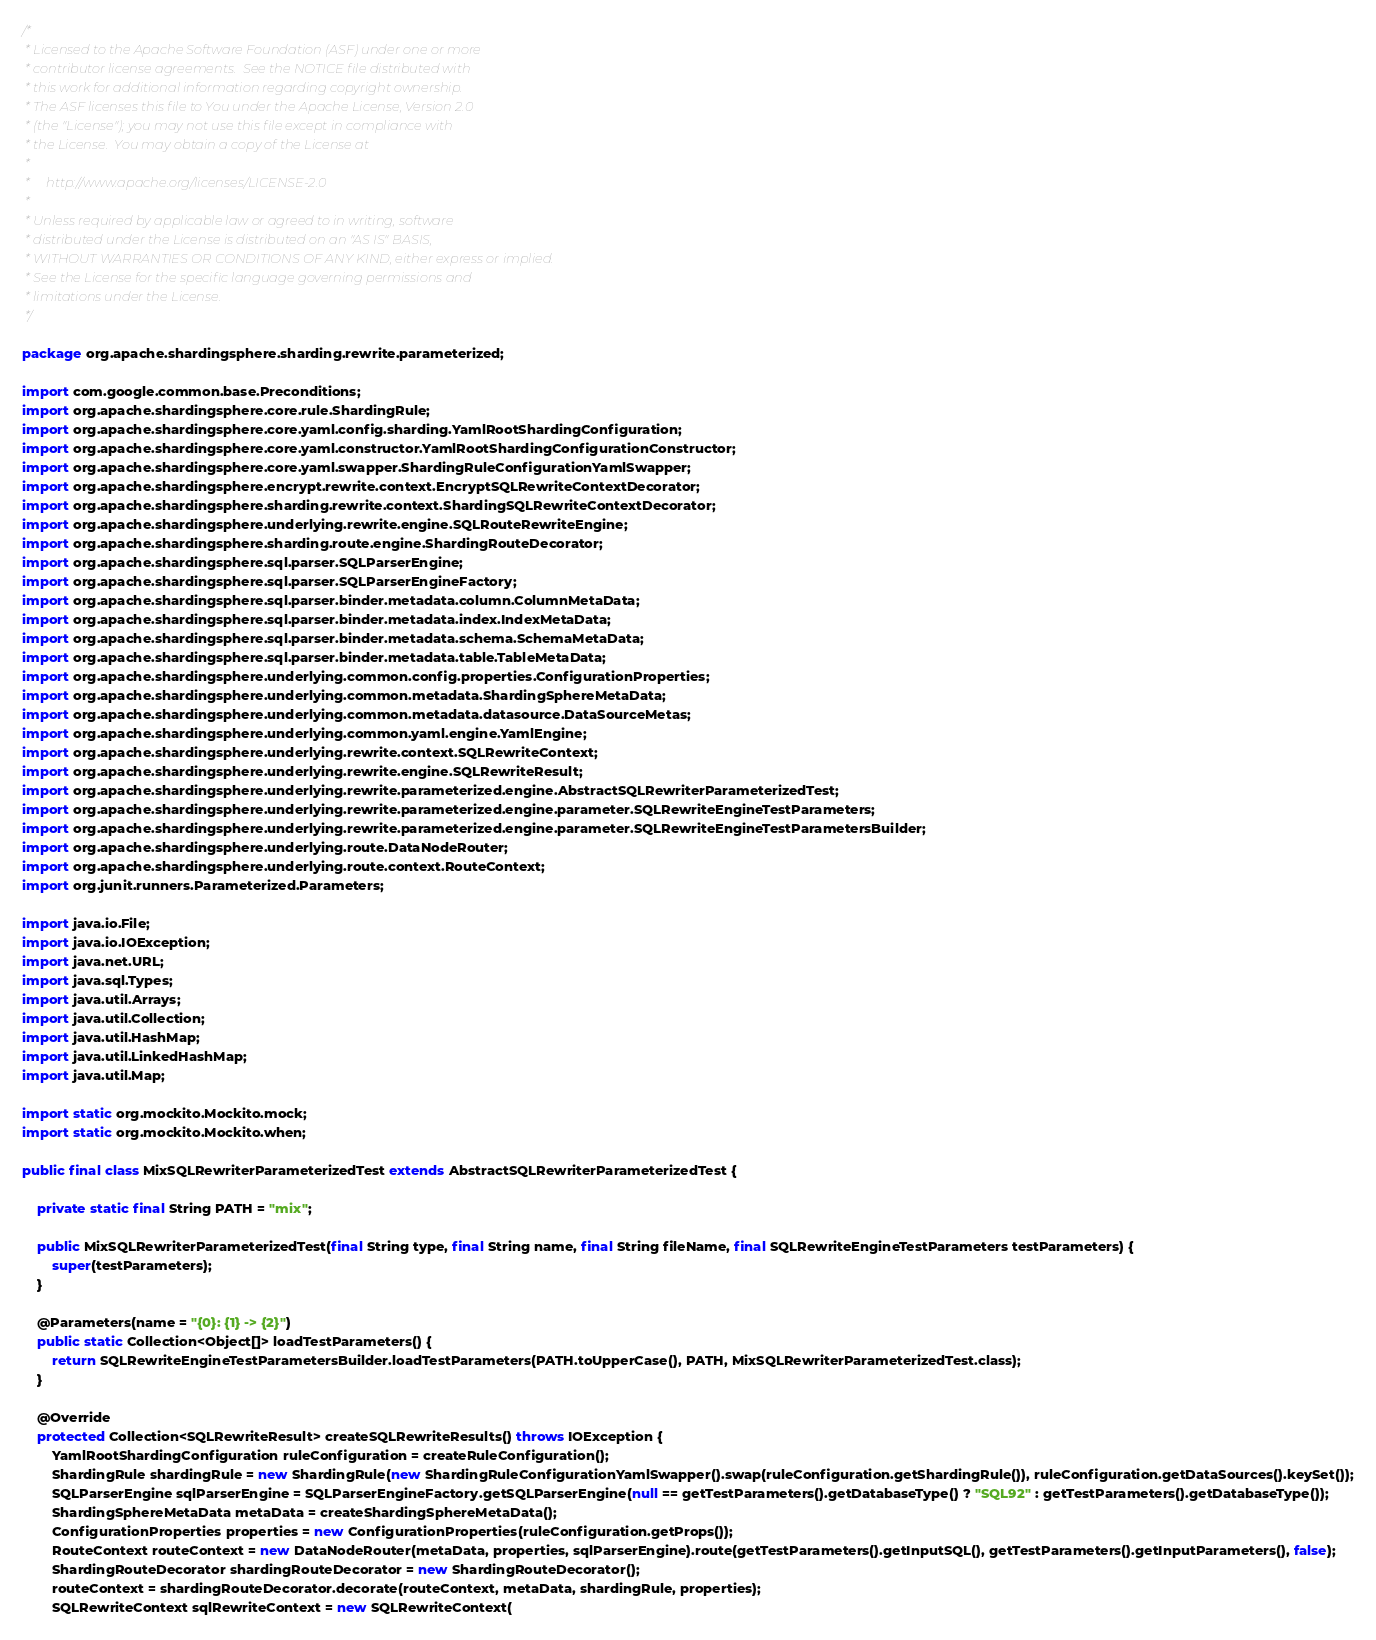<code> <loc_0><loc_0><loc_500><loc_500><_Java_>/*
 * Licensed to the Apache Software Foundation (ASF) under one or more
 * contributor license agreements.  See the NOTICE file distributed with
 * this work for additional information regarding copyright ownership.
 * The ASF licenses this file to You under the Apache License, Version 2.0
 * (the "License"); you may not use this file except in compliance with
 * the License.  You may obtain a copy of the License at
 *
 *     http://www.apache.org/licenses/LICENSE-2.0
 *
 * Unless required by applicable law or agreed to in writing, software
 * distributed under the License is distributed on an "AS IS" BASIS,
 * WITHOUT WARRANTIES OR CONDITIONS OF ANY KIND, either express or implied.
 * See the License for the specific language governing permissions and
 * limitations under the License.
 */

package org.apache.shardingsphere.sharding.rewrite.parameterized;

import com.google.common.base.Preconditions;
import org.apache.shardingsphere.core.rule.ShardingRule;
import org.apache.shardingsphere.core.yaml.config.sharding.YamlRootShardingConfiguration;
import org.apache.shardingsphere.core.yaml.constructor.YamlRootShardingConfigurationConstructor;
import org.apache.shardingsphere.core.yaml.swapper.ShardingRuleConfigurationYamlSwapper;
import org.apache.shardingsphere.encrypt.rewrite.context.EncryptSQLRewriteContextDecorator;
import org.apache.shardingsphere.sharding.rewrite.context.ShardingSQLRewriteContextDecorator;
import org.apache.shardingsphere.underlying.rewrite.engine.SQLRouteRewriteEngine;
import org.apache.shardingsphere.sharding.route.engine.ShardingRouteDecorator;
import org.apache.shardingsphere.sql.parser.SQLParserEngine;
import org.apache.shardingsphere.sql.parser.SQLParserEngineFactory;
import org.apache.shardingsphere.sql.parser.binder.metadata.column.ColumnMetaData;
import org.apache.shardingsphere.sql.parser.binder.metadata.index.IndexMetaData;
import org.apache.shardingsphere.sql.parser.binder.metadata.schema.SchemaMetaData;
import org.apache.shardingsphere.sql.parser.binder.metadata.table.TableMetaData;
import org.apache.shardingsphere.underlying.common.config.properties.ConfigurationProperties;
import org.apache.shardingsphere.underlying.common.metadata.ShardingSphereMetaData;
import org.apache.shardingsphere.underlying.common.metadata.datasource.DataSourceMetas;
import org.apache.shardingsphere.underlying.common.yaml.engine.YamlEngine;
import org.apache.shardingsphere.underlying.rewrite.context.SQLRewriteContext;
import org.apache.shardingsphere.underlying.rewrite.engine.SQLRewriteResult;
import org.apache.shardingsphere.underlying.rewrite.parameterized.engine.AbstractSQLRewriterParameterizedTest;
import org.apache.shardingsphere.underlying.rewrite.parameterized.engine.parameter.SQLRewriteEngineTestParameters;
import org.apache.shardingsphere.underlying.rewrite.parameterized.engine.parameter.SQLRewriteEngineTestParametersBuilder;
import org.apache.shardingsphere.underlying.route.DataNodeRouter;
import org.apache.shardingsphere.underlying.route.context.RouteContext;
import org.junit.runners.Parameterized.Parameters;

import java.io.File;
import java.io.IOException;
import java.net.URL;
import java.sql.Types;
import java.util.Arrays;
import java.util.Collection;
import java.util.HashMap;
import java.util.LinkedHashMap;
import java.util.Map;

import static org.mockito.Mockito.mock;
import static org.mockito.Mockito.when;

public final class MixSQLRewriterParameterizedTest extends AbstractSQLRewriterParameterizedTest {
    
    private static final String PATH = "mix";
    
    public MixSQLRewriterParameterizedTest(final String type, final String name, final String fileName, final SQLRewriteEngineTestParameters testParameters) {
        super(testParameters);
    }
    
    @Parameters(name = "{0}: {1} -> {2}")
    public static Collection<Object[]> loadTestParameters() {
        return SQLRewriteEngineTestParametersBuilder.loadTestParameters(PATH.toUpperCase(), PATH, MixSQLRewriterParameterizedTest.class);
    }
    
    @Override
    protected Collection<SQLRewriteResult> createSQLRewriteResults() throws IOException {
        YamlRootShardingConfiguration ruleConfiguration = createRuleConfiguration();
        ShardingRule shardingRule = new ShardingRule(new ShardingRuleConfigurationYamlSwapper().swap(ruleConfiguration.getShardingRule()), ruleConfiguration.getDataSources().keySet());
        SQLParserEngine sqlParserEngine = SQLParserEngineFactory.getSQLParserEngine(null == getTestParameters().getDatabaseType() ? "SQL92" : getTestParameters().getDatabaseType());
        ShardingSphereMetaData metaData = createShardingSphereMetaData();
        ConfigurationProperties properties = new ConfigurationProperties(ruleConfiguration.getProps());
        RouteContext routeContext = new DataNodeRouter(metaData, properties, sqlParserEngine).route(getTestParameters().getInputSQL(), getTestParameters().getInputParameters(), false);
        ShardingRouteDecorator shardingRouteDecorator = new ShardingRouteDecorator();
        routeContext = shardingRouteDecorator.decorate(routeContext, metaData, shardingRule, properties);
        SQLRewriteContext sqlRewriteContext = new SQLRewriteContext(</code> 